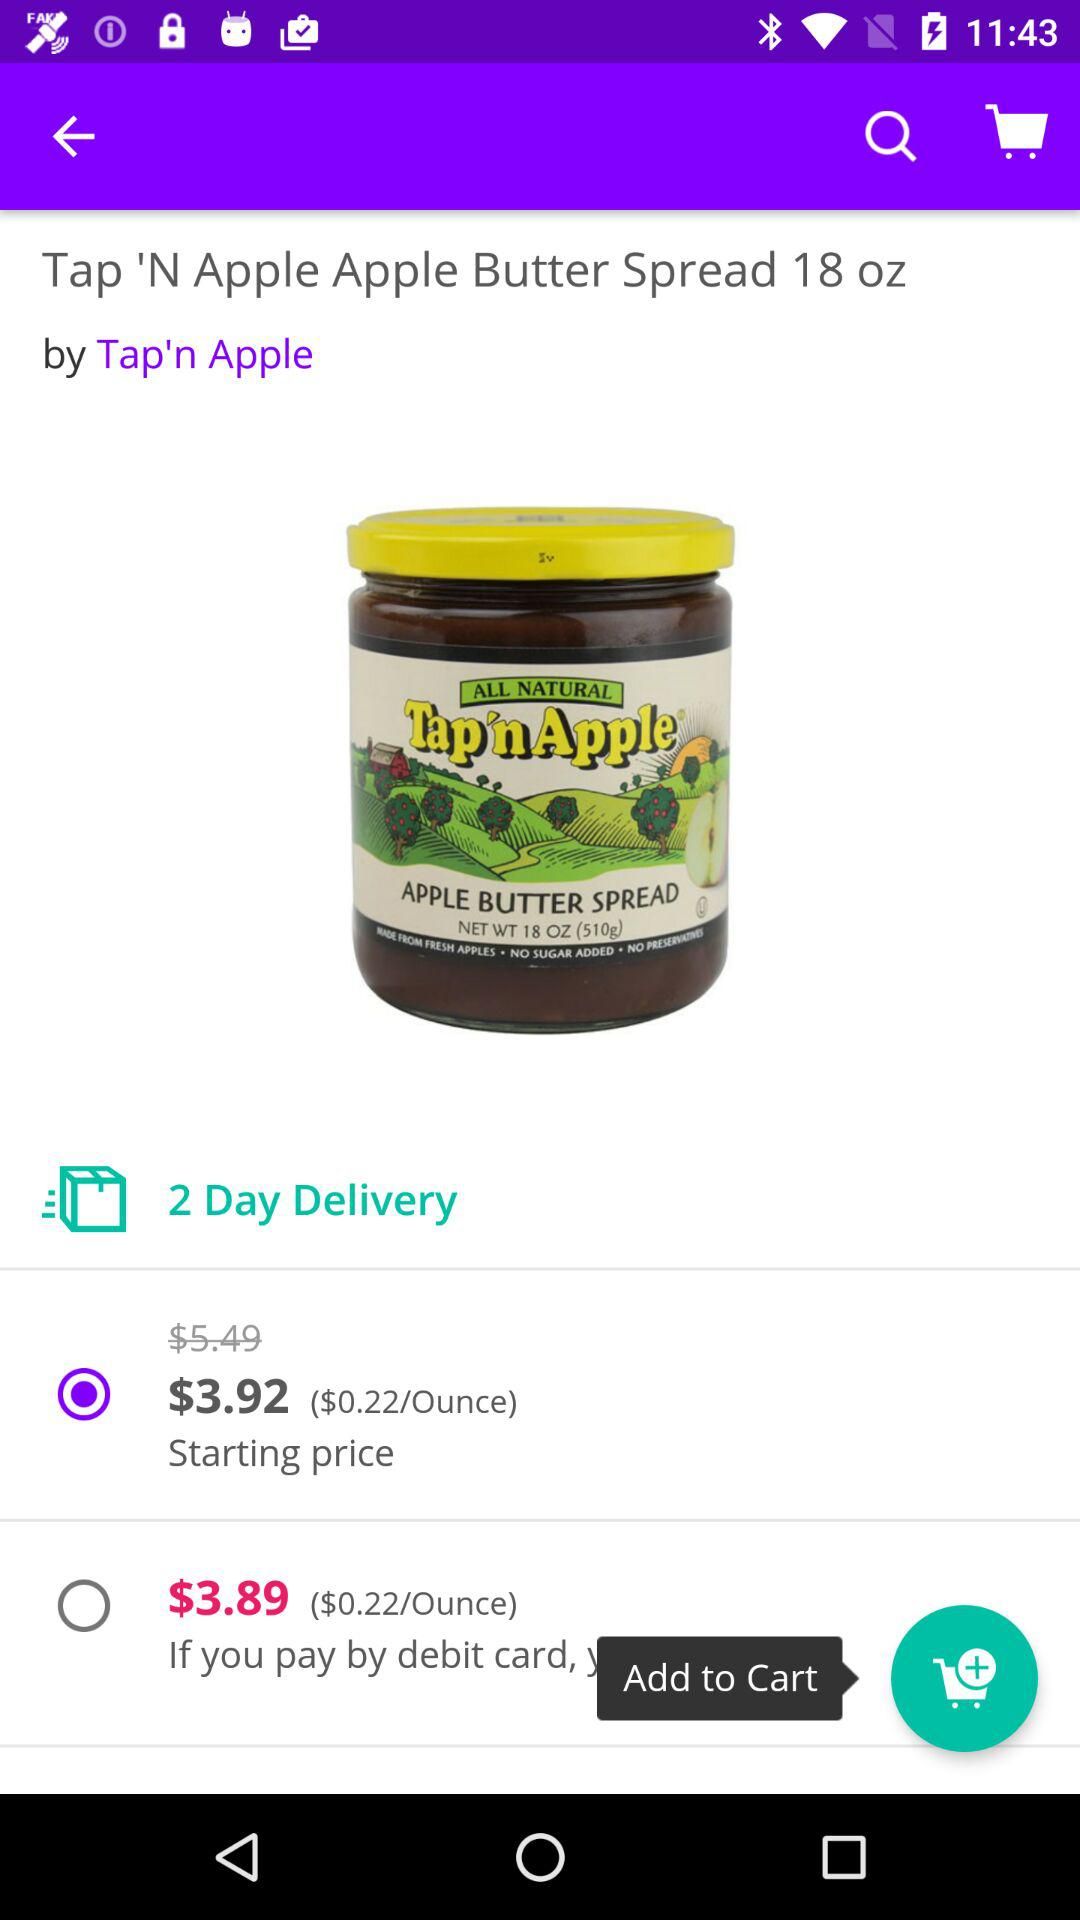What's the starting price? The starting price is $3.92. 